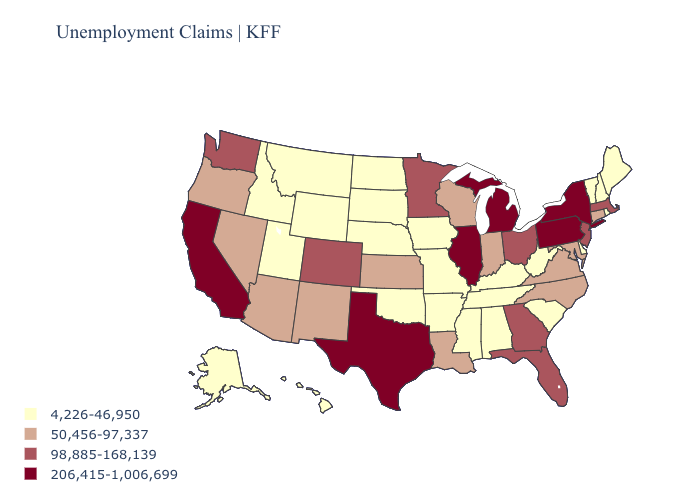Does Hawaii have a higher value than Rhode Island?
Be succinct. No. Does California have the highest value in the West?
Keep it brief. Yes. Does Delaware have the lowest value in the USA?
Quick response, please. Yes. Does Ohio have the lowest value in the MidWest?
Quick response, please. No. Name the states that have a value in the range 4,226-46,950?
Answer briefly. Alabama, Alaska, Arkansas, Delaware, Hawaii, Idaho, Iowa, Kentucky, Maine, Mississippi, Missouri, Montana, Nebraska, New Hampshire, North Dakota, Oklahoma, Rhode Island, South Carolina, South Dakota, Tennessee, Utah, Vermont, West Virginia, Wyoming. Is the legend a continuous bar?
Concise answer only. No. Does the first symbol in the legend represent the smallest category?
Short answer required. Yes. Which states hav the highest value in the MidWest?
Quick response, please. Illinois, Michigan. Name the states that have a value in the range 4,226-46,950?
Answer briefly. Alabama, Alaska, Arkansas, Delaware, Hawaii, Idaho, Iowa, Kentucky, Maine, Mississippi, Missouri, Montana, Nebraska, New Hampshire, North Dakota, Oklahoma, Rhode Island, South Carolina, South Dakota, Tennessee, Utah, Vermont, West Virginia, Wyoming. What is the value of Rhode Island?
Short answer required. 4,226-46,950. Among the states that border Oregon , which have the highest value?
Be succinct. California. What is the highest value in states that border Kentucky?
Give a very brief answer. 206,415-1,006,699. Does the first symbol in the legend represent the smallest category?
Short answer required. Yes. Does Pennsylvania have a higher value than Louisiana?
Give a very brief answer. Yes. What is the value of New Jersey?
Answer briefly. 98,885-168,139. 